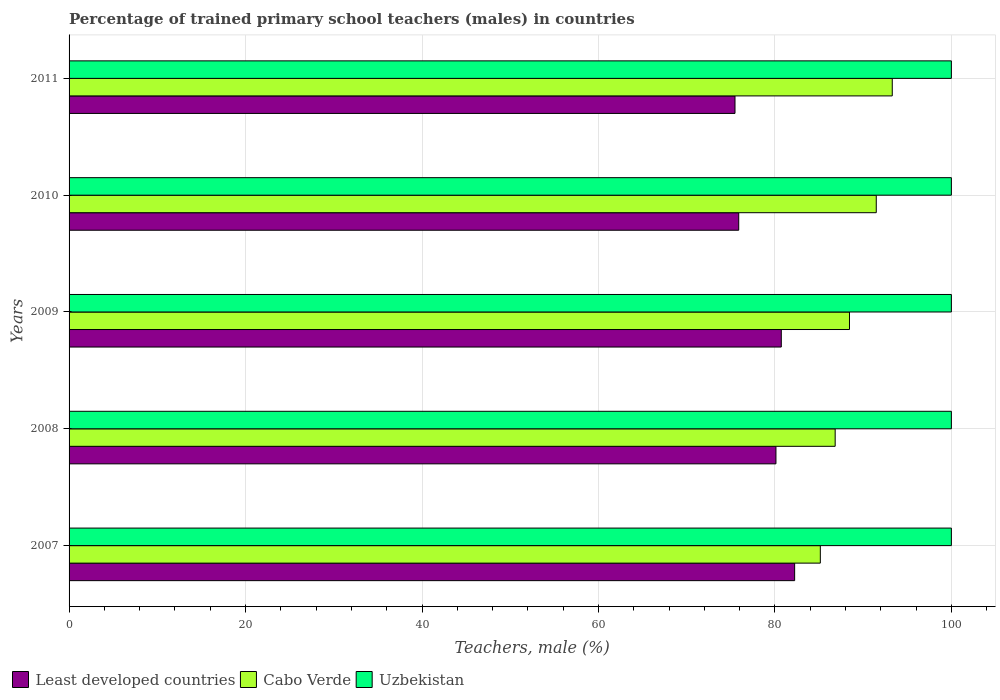How many groups of bars are there?
Ensure brevity in your answer.  5. Are the number of bars per tick equal to the number of legend labels?
Ensure brevity in your answer.  Yes. How many bars are there on the 4th tick from the top?
Provide a short and direct response. 3. How many bars are there on the 4th tick from the bottom?
Provide a succinct answer. 3. What is the label of the 2nd group of bars from the top?
Your answer should be very brief. 2010. What is the percentage of trained primary school teachers (males) in Least developed countries in 2009?
Your answer should be very brief. 80.72. Across all years, what is the maximum percentage of trained primary school teachers (males) in Uzbekistan?
Offer a very short reply. 100. Across all years, what is the minimum percentage of trained primary school teachers (males) in Cabo Verde?
Ensure brevity in your answer.  85.15. In which year was the percentage of trained primary school teachers (males) in Cabo Verde maximum?
Your answer should be very brief. 2011. What is the difference between the percentage of trained primary school teachers (males) in Least developed countries in 2009 and that in 2011?
Make the answer very short. 5.25. What is the difference between the percentage of trained primary school teachers (males) in Least developed countries in 2009 and the percentage of trained primary school teachers (males) in Uzbekistan in 2011?
Your response must be concise. -19.28. What is the average percentage of trained primary school teachers (males) in Cabo Verde per year?
Provide a short and direct response. 89.04. In the year 2011, what is the difference between the percentage of trained primary school teachers (males) in Uzbekistan and percentage of trained primary school teachers (males) in Least developed countries?
Offer a terse response. 24.52. Is the percentage of trained primary school teachers (males) in Least developed countries in 2009 less than that in 2011?
Ensure brevity in your answer.  No. What is the difference between the highest and the second highest percentage of trained primary school teachers (males) in Cabo Verde?
Provide a succinct answer. 1.81. What is the difference between the highest and the lowest percentage of trained primary school teachers (males) in Cabo Verde?
Provide a succinct answer. 8.15. In how many years, is the percentage of trained primary school teachers (males) in Uzbekistan greater than the average percentage of trained primary school teachers (males) in Uzbekistan taken over all years?
Your response must be concise. 0. Is the sum of the percentage of trained primary school teachers (males) in Uzbekistan in 2007 and 2009 greater than the maximum percentage of trained primary school teachers (males) in Cabo Verde across all years?
Your answer should be compact. Yes. What does the 3rd bar from the top in 2011 represents?
Keep it short and to the point. Least developed countries. What does the 2nd bar from the bottom in 2010 represents?
Ensure brevity in your answer.  Cabo Verde. Is it the case that in every year, the sum of the percentage of trained primary school teachers (males) in Cabo Verde and percentage of trained primary school teachers (males) in Least developed countries is greater than the percentage of trained primary school teachers (males) in Uzbekistan?
Make the answer very short. Yes. How many bars are there?
Ensure brevity in your answer.  15. Are all the bars in the graph horizontal?
Provide a short and direct response. Yes. How many years are there in the graph?
Your answer should be compact. 5. What is the difference between two consecutive major ticks on the X-axis?
Your response must be concise. 20. Does the graph contain any zero values?
Your answer should be compact. No. How are the legend labels stacked?
Your answer should be very brief. Horizontal. What is the title of the graph?
Provide a succinct answer. Percentage of trained primary school teachers (males) in countries. Does "Least developed countries" appear as one of the legend labels in the graph?
Your response must be concise. Yes. What is the label or title of the X-axis?
Offer a terse response. Teachers, male (%). What is the Teachers, male (%) of Least developed countries in 2007?
Keep it short and to the point. 82.24. What is the Teachers, male (%) of Cabo Verde in 2007?
Keep it short and to the point. 85.15. What is the Teachers, male (%) in Least developed countries in 2008?
Offer a very short reply. 80.12. What is the Teachers, male (%) of Cabo Verde in 2008?
Provide a succinct answer. 86.83. What is the Teachers, male (%) in Uzbekistan in 2008?
Give a very brief answer. 100. What is the Teachers, male (%) of Least developed countries in 2009?
Your response must be concise. 80.72. What is the Teachers, male (%) in Cabo Verde in 2009?
Your answer should be very brief. 88.45. What is the Teachers, male (%) of Uzbekistan in 2009?
Make the answer very short. 100. What is the Teachers, male (%) of Least developed countries in 2010?
Your response must be concise. 75.9. What is the Teachers, male (%) in Cabo Verde in 2010?
Ensure brevity in your answer.  91.49. What is the Teachers, male (%) of Least developed countries in 2011?
Your answer should be compact. 75.48. What is the Teachers, male (%) in Cabo Verde in 2011?
Your response must be concise. 93.3. Across all years, what is the maximum Teachers, male (%) in Least developed countries?
Your answer should be compact. 82.24. Across all years, what is the maximum Teachers, male (%) of Cabo Verde?
Make the answer very short. 93.3. Across all years, what is the minimum Teachers, male (%) in Least developed countries?
Ensure brevity in your answer.  75.48. Across all years, what is the minimum Teachers, male (%) of Cabo Verde?
Give a very brief answer. 85.15. What is the total Teachers, male (%) of Least developed countries in the graph?
Give a very brief answer. 394.45. What is the total Teachers, male (%) in Cabo Verde in the graph?
Your answer should be compact. 445.21. What is the difference between the Teachers, male (%) in Least developed countries in 2007 and that in 2008?
Provide a short and direct response. 2.12. What is the difference between the Teachers, male (%) in Cabo Verde in 2007 and that in 2008?
Keep it short and to the point. -1.68. What is the difference between the Teachers, male (%) of Least developed countries in 2007 and that in 2009?
Your response must be concise. 1.51. What is the difference between the Teachers, male (%) of Cabo Verde in 2007 and that in 2009?
Your answer should be compact. -3.31. What is the difference between the Teachers, male (%) of Least developed countries in 2007 and that in 2010?
Your response must be concise. 6.34. What is the difference between the Teachers, male (%) in Cabo Verde in 2007 and that in 2010?
Offer a terse response. -6.34. What is the difference between the Teachers, male (%) of Uzbekistan in 2007 and that in 2010?
Your answer should be compact. 0. What is the difference between the Teachers, male (%) of Least developed countries in 2007 and that in 2011?
Make the answer very short. 6.76. What is the difference between the Teachers, male (%) in Cabo Verde in 2007 and that in 2011?
Give a very brief answer. -8.15. What is the difference between the Teachers, male (%) in Least developed countries in 2008 and that in 2009?
Your response must be concise. -0.61. What is the difference between the Teachers, male (%) in Cabo Verde in 2008 and that in 2009?
Provide a succinct answer. -1.62. What is the difference between the Teachers, male (%) in Least developed countries in 2008 and that in 2010?
Your answer should be very brief. 4.22. What is the difference between the Teachers, male (%) in Cabo Verde in 2008 and that in 2010?
Provide a short and direct response. -4.66. What is the difference between the Teachers, male (%) in Uzbekistan in 2008 and that in 2010?
Give a very brief answer. 0. What is the difference between the Teachers, male (%) of Least developed countries in 2008 and that in 2011?
Provide a short and direct response. 4.64. What is the difference between the Teachers, male (%) of Cabo Verde in 2008 and that in 2011?
Ensure brevity in your answer.  -6.47. What is the difference between the Teachers, male (%) of Least developed countries in 2009 and that in 2010?
Offer a terse response. 4.83. What is the difference between the Teachers, male (%) in Cabo Verde in 2009 and that in 2010?
Your answer should be compact. -3.03. What is the difference between the Teachers, male (%) in Least developed countries in 2009 and that in 2011?
Your response must be concise. 5.25. What is the difference between the Teachers, male (%) in Cabo Verde in 2009 and that in 2011?
Your answer should be very brief. -4.85. What is the difference between the Teachers, male (%) of Least developed countries in 2010 and that in 2011?
Your answer should be compact. 0.42. What is the difference between the Teachers, male (%) of Cabo Verde in 2010 and that in 2011?
Give a very brief answer. -1.81. What is the difference between the Teachers, male (%) in Least developed countries in 2007 and the Teachers, male (%) in Cabo Verde in 2008?
Offer a terse response. -4.59. What is the difference between the Teachers, male (%) in Least developed countries in 2007 and the Teachers, male (%) in Uzbekistan in 2008?
Your response must be concise. -17.76. What is the difference between the Teachers, male (%) in Cabo Verde in 2007 and the Teachers, male (%) in Uzbekistan in 2008?
Provide a succinct answer. -14.85. What is the difference between the Teachers, male (%) in Least developed countries in 2007 and the Teachers, male (%) in Cabo Verde in 2009?
Give a very brief answer. -6.22. What is the difference between the Teachers, male (%) in Least developed countries in 2007 and the Teachers, male (%) in Uzbekistan in 2009?
Ensure brevity in your answer.  -17.76. What is the difference between the Teachers, male (%) in Cabo Verde in 2007 and the Teachers, male (%) in Uzbekistan in 2009?
Keep it short and to the point. -14.85. What is the difference between the Teachers, male (%) in Least developed countries in 2007 and the Teachers, male (%) in Cabo Verde in 2010?
Your answer should be very brief. -9.25. What is the difference between the Teachers, male (%) of Least developed countries in 2007 and the Teachers, male (%) of Uzbekistan in 2010?
Make the answer very short. -17.76. What is the difference between the Teachers, male (%) of Cabo Verde in 2007 and the Teachers, male (%) of Uzbekistan in 2010?
Give a very brief answer. -14.85. What is the difference between the Teachers, male (%) of Least developed countries in 2007 and the Teachers, male (%) of Cabo Verde in 2011?
Provide a succinct answer. -11.06. What is the difference between the Teachers, male (%) of Least developed countries in 2007 and the Teachers, male (%) of Uzbekistan in 2011?
Your answer should be very brief. -17.76. What is the difference between the Teachers, male (%) of Cabo Verde in 2007 and the Teachers, male (%) of Uzbekistan in 2011?
Offer a terse response. -14.85. What is the difference between the Teachers, male (%) of Least developed countries in 2008 and the Teachers, male (%) of Cabo Verde in 2009?
Ensure brevity in your answer.  -8.34. What is the difference between the Teachers, male (%) in Least developed countries in 2008 and the Teachers, male (%) in Uzbekistan in 2009?
Offer a terse response. -19.88. What is the difference between the Teachers, male (%) of Cabo Verde in 2008 and the Teachers, male (%) of Uzbekistan in 2009?
Give a very brief answer. -13.17. What is the difference between the Teachers, male (%) of Least developed countries in 2008 and the Teachers, male (%) of Cabo Verde in 2010?
Offer a very short reply. -11.37. What is the difference between the Teachers, male (%) of Least developed countries in 2008 and the Teachers, male (%) of Uzbekistan in 2010?
Offer a very short reply. -19.88. What is the difference between the Teachers, male (%) of Cabo Verde in 2008 and the Teachers, male (%) of Uzbekistan in 2010?
Offer a terse response. -13.17. What is the difference between the Teachers, male (%) of Least developed countries in 2008 and the Teachers, male (%) of Cabo Verde in 2011?
Your answer should be compact. -13.18. What is the difference between the Teachers, male (%) in Least developed countries in 2008 and the Teachers, male (%) in Uzbekistan in 2011?
Keep it short and to the point. -19.88. What is the difference between the Teachers, male (%) of Cabo Verde in 2008 and the Teachers, male (%) of Uzbekistan in 2011?
Offer a terse response. -13.17. What is the difference between the Teachers, male (%) of Least developed countries in 2009 and the Teachers, male (%) of Cabo Verde in 2010?
Keep it short and to the point. -10.76. What is the difference between the Teachers, male (%) in Least developed countries in 2009 and the Teachers, male (%) in Uzbekistan in 2010?
Provide a short and direct response. -19.28. What is the difference between the Teachers, male (%) in Cabo Verde in 2009 and the Teachers, male (%) in Uzbekistan in 2010?
Offer a very short reply. -11.55. What is the difference between the Teachers, male (%) in Least developed countries in 2009 and the Teachers, male (%) in Cabo Verde in 2011?
Keep it short and to the point. -12.58. What is the difference between the Teachers, male (%) of Least developed countries in 2009 and the Teachers, male (%) of Uzbekistan in 2011?
Your response must be concise. -19.28. What is the difference between the Teachers, male (%) of Cabo Verde in 2009 and the Teachers, male (%) of Uzbekistan in 2011?
Offer a terse response. -11.55. What is the difference between the Teachers, male (%) in Least developed countries in 2010 and the Teachers, male (%) in Cabo Verde in 2011?
Offer a terse response. -17.4. What is the difference between the Teachers, male (%) of Least developed countries in 2010 and the Teachers, male (%) of Uzbekistan in 2011?
Offer a terse response. -24.1. What is the difference between the Teachers, male (%) in Cabo Verde in 2010 and the Teachers, male (%) in Uzbekistan in 2011?
Offer a terse response. -8.51. What is the average Teachers, male (%) in Least developed countries per year?
Your answer should be very brief. 78.89. What is the average Teachers, male (%) of Cabo Verde per year?
Your response must be concise. 89.04. In the year 2007, what is the difference between the Teachers, male (%) of Least developed countries and Teachers, male (%) of Cabo Verde?
Keep it short and to the point. -2.91. In the year 2007, what is the difference between the Teachers, male (%) in Least developed countries and Teachers, male (%) in Uzbekistan?
Ensure brevity in your answer.  -17.76. In the year 2007, what is the difference between the Teachers, male (%) of Cabo Verde and Teachers, male (%) of Uzbekistan?
Your answer should be compact. -14.85. In the year 2008, what is the difference between the Teachers, male (%) in Least developed countries and Teachers, male (%) in Cabo Verde?
Ensure brevity in your answer.  -6.71. In the year 2008, what is the difference between the Teachers, male (%) of Least developed countries and Teachers, male (%) of Uzbekistan?
Keep it short and to the point. -19.88. In the year 2008, what is the difference between the Teachers, male (%) in Cabo Verde and Teachers, male (%) in Uzbekistan?
Make the answer very short. -13.17. In the year 2009, what is the difference between the Teachers, male (%) of Least developed countries and Teachers, male (%) of Cabo Verde?
Make the answer very short. -7.73. In the year 2009, what is the difference between the Teachers, male (%) in Least developed countries and Teachers, male (%) in Uzbekistan?
Offer a terse response. -19.28. In the year 2009, what is the difference between the Teachers, male (%) in Cabo Verde and Teachers, male (%) in Uzbekistan?
Your answer should be very brief. -11.55. In the year 2010, what is the difference between the Teachers, male (%) in Least developed countries and Teachers, male (%) in Cabo Verde?
Keep it short and to the point. -15.59. In the year 2010, what is the difference between the Teachers, male (%) of Least developed countries and Teachers, male (%) of Uzbekistan?
Your answer should be very brief. -24.1. In the year 2010, what is the difference between the Teachers, male (%) of Cabo Verde and Teachers, male (%) of Uzbekistan?
Make the answer very short. -8.51. In the year 2011, what is the difference between the Teachers, male (%) in Least developed countries and Teachers, male (%) in Cabo Verde?
Your response must be concise. -17.82. In the year 2011, what is the difference between the Teachers, male (%) of Least developed countries and Teachers, male (%) of Uzbekistan?
Provide a short and direct response. -24.52. What is the ratio of the Teachers, male (%) in Least developed countries in 2007 to that in 2008?
Keep it short and to the point. 1.03. What is the ratio of the Teachers, male (%) of Cabo Verde in 2007 to that in 2008?
Your answer should be compact. 0.98. What is the ratio of the Teachers, male (%) in Uzbekistan in 2007 to that in 2008?
Offer a terse response. 1. What is the ratio of the Teachers, male (%) in Least developed countries in 2007 to that in 2009?
Keep it short and to the point. 1.02. What is the ratio of the Teachers, male (%) in Cabo Verde in 2007 to that in 2009?
Your answer should be compact. 0.96. What is the ratio of the Teachers, male (%) in Uzbekistan in 2007 to that in 2009?
Give a very brief answer. 1. What is the ratio of the Teachers, male (%) in Least developed countries in 2007 to that in 2010?
Keep it short and to the point. 1.08. What is the ratio of the Teachers, male (%) of Cabo Verde in 2007 to that in 2010?
Offer a very short reply. 0.93. What is the ratio of the Teachers, male (%) of Uzbekistan in 2007 to that in 2010?
Provide a succinct answer. 1. What is the ratio of the Teachers, male (%) in Least developed countries in 2007 to that in 2011?
Provide a succinct answer. 1.09. What is the ratio of the Teachers, male (%) of Cabo Verde in 2007 to that in 2011?
Give a very brief answer. 0.91. What is the ratio of the Teachers, male (%) of Cabo Verde in 2008 to that in 2009?
Your answer should be compact. 0.98. What is the ratio of the Teachers, male (%) of Uzbekistan in 2008 to that in 2009?
Your answer should be very brief. 1. What is the ratio of the Teachers, male (%) in Least developed countries in 2008 to that in 2010?
Offer a terse response. 1.06. What is the ratio of the Teachers, male (%) of Cabo Verde in 2008 to that in 2010?
Your answer should be compact. 0.95. What is the ratio of the Teachers, male (%) of Least developed countries in 2008 to that in 2011?
Make the answer very short. 1.06. What is the ratio of the Teachers, male (%) in Cabo Verde in 2008 to that in 2011?
Provide a short and direct response. 0.93. What is the ratio of the Teachers, male (%) of Uzbekistan in 2008 to that in 2011?
Offer a very short reply. 1. What is the ratio of the Teachers, male (%) of Least developed countries in 2009 to that in 2010?
Keep it short and to the point. 1.06. What is the ratio of the Teachers, male (%) in Cabo Verde in 2009 to that in 2010?
Keep it short and to the point. 0.97. What is the ratio of the Teachers, male (%) of Least developed countries in 2009 to that in 2011?
Ensure brevity in your answer.  1.07. What is the ratio of the Teachers, male (%) of Cabo Verde in 2009 to that in 2011?
Your answer should be compact. 0.95. What is the ratio of the Teachers, male (%) in Least developed countries in 2010 to that in 2011?
Your answer should be very brief. 1.01. What is the ratio of the Teachers, male (%) in Cabo Verde in 2010 to that in 2011?
Provide a short and direct response. 0.98. What is the difference between the highest and the second highest Teachers, male (%) of Least developed countries?
Provide a short and direct response. 1.51. What is the difference between the highest and the second highest Teachers, male (%) in Cabo Verde?
Keep it short and to the point. 1.81. What is the difference between the highest and the second highest Teachers, male (%) of Uzbekistan?
Ensure brevity in your answer.  0. What is the difference between the highest and the lowest Teachers, male (%) in Least developed countries?
Provide a short and direct response. 6.76. What is the difference between the highest and the lowest Teachers, male (%) of Cabo Verde?
Make the answer very short. 8.15. 